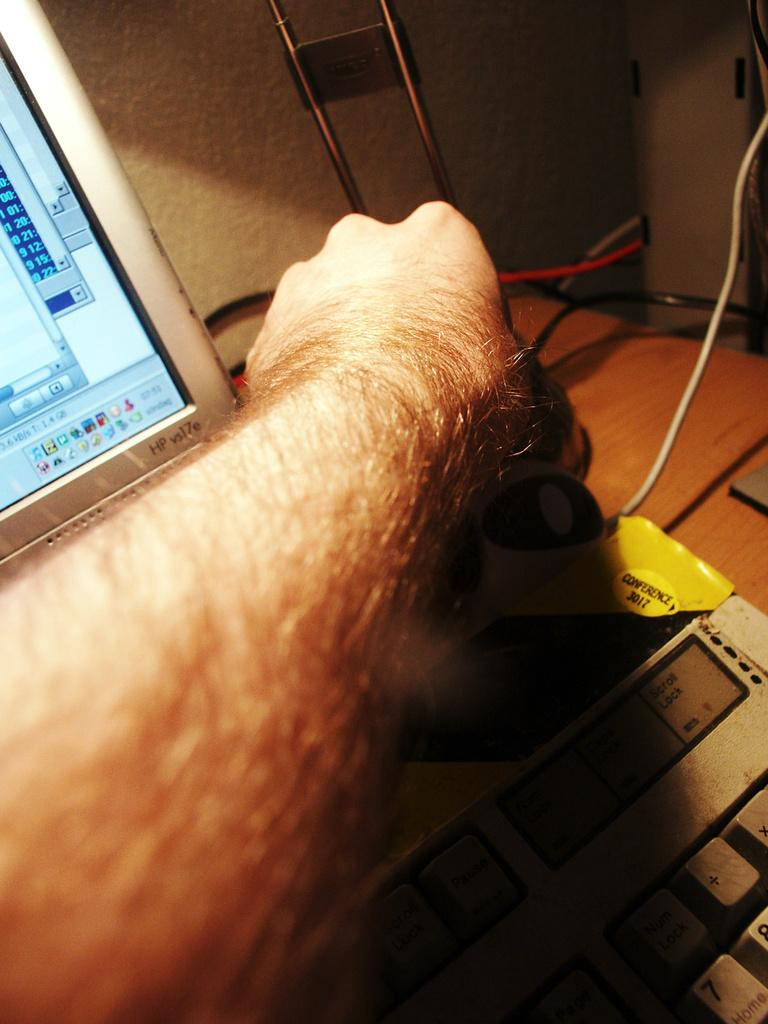<image>
Relay a brief, clear account of the picture shown. An HP vs17e monitor sits on a wood desk 